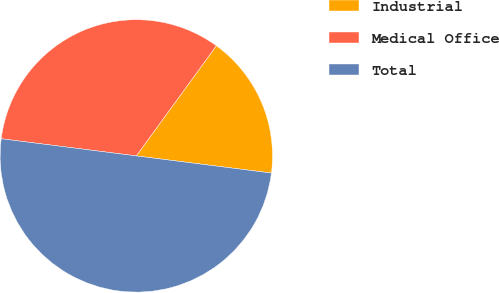<chart> <loc_0><loc_0><loc_500><loc_500><pie_chart><fcel>Industrial<fcel>Medical Office<fcel>Total<nl><fcel>17.01%<fcel>32.99%<fcel>50.0%<nl></chart> 